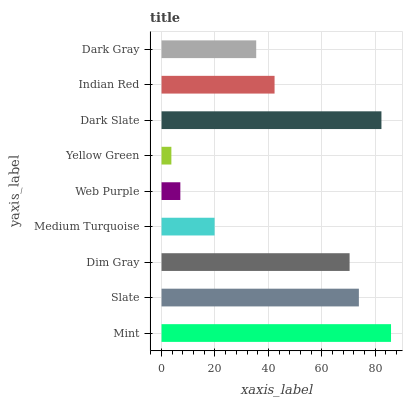Is Yellow Green the minimum?
Answer yes or no. Yes. Is Mint the maximum?
Answer yes or no. Yes. Is Slate the minimum?
Answer yes or no. No. Is Slate the maximum?
Answer yes or no. No. Is Mint greater than Slate?
Answer yes or no. Yes. Is Slate less than Mint?
Answer yes or no. Yes. Is Slate greater than Mint?
Answer yes or no. No. Is Mint less than Slate?
Answer yes or no. No. Is Indian Red the high median?
Answer yes or no. Yes. Is Indian Red the low median?
Answer yes or no. Yes. Is Dark Gray the high median?
Answer yes or no. No. Is Medium Turquoise the low median?
Answer yes or no. No. 